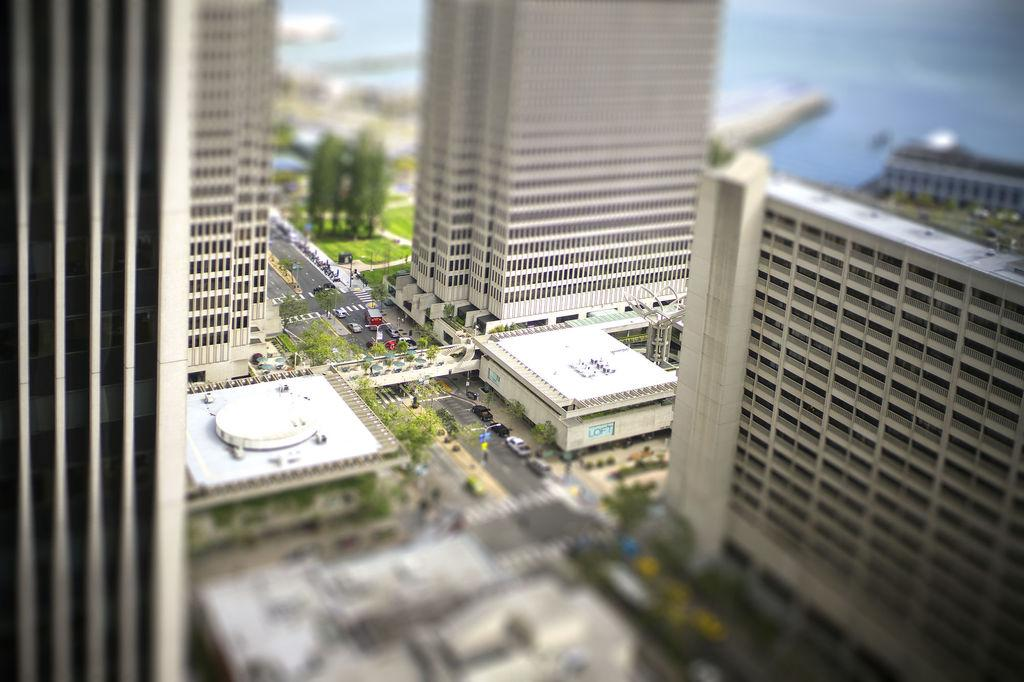What is located in the center of the image? There are buildings in the center of the image. What type of natural elements can be seen in the image? There are trees and grass in the image. What is happening on the road in the image? There are vehicles on the road in the image. What structures are present in the image? There are poles and a bridge in the image. What additional object can be seen in the image? There is a banner in the image. Can you describe the overall setting of the image? The image features a combination of urban and natural elements, including buildings, trees, grass, vehicles, poles, a bridge, and a banner. What type of punishment is being administered to the person holding the vest in the image? There is no person holding a vest or any indication of punishment in the image. How many volleyballs can be seen in the image? There are no volleyballs present in the image. 